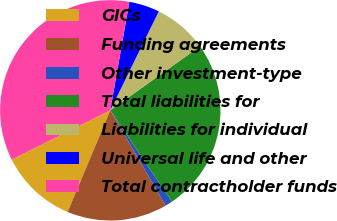Convert chart to OTSL. <chart><loc_0><loc_0><loc_500><loc_500><pie_chart><fcel>GICs<fcel>Funding agreements<fcel>Other investment-type<fcel>Total liabilities for<fcel>Liabilities for individual<fcel>Universal life and other<fcel>Total contractholder funds<nl><fcel>11.3%<fcel>14.7%<fcel>1.08%<fcel>25.41%<fcel>7.89%<fcel>4.48%<fcel>35.14%<nl></chart> 